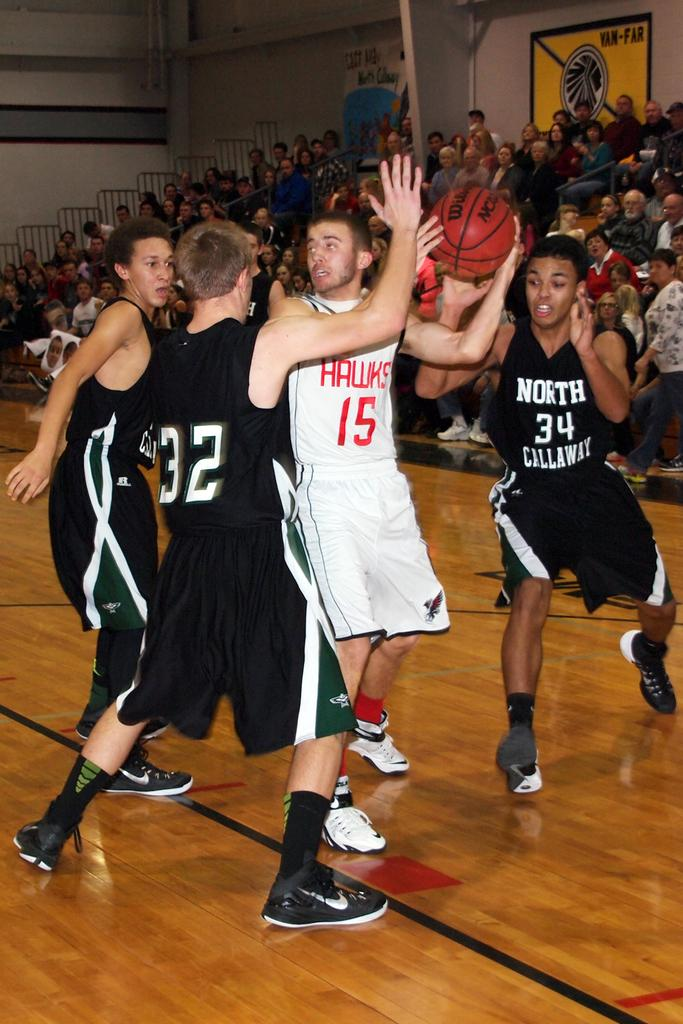Provide a one-sentence caption for the provided image. basketball game between hawks in white and north callaway wearing black. 